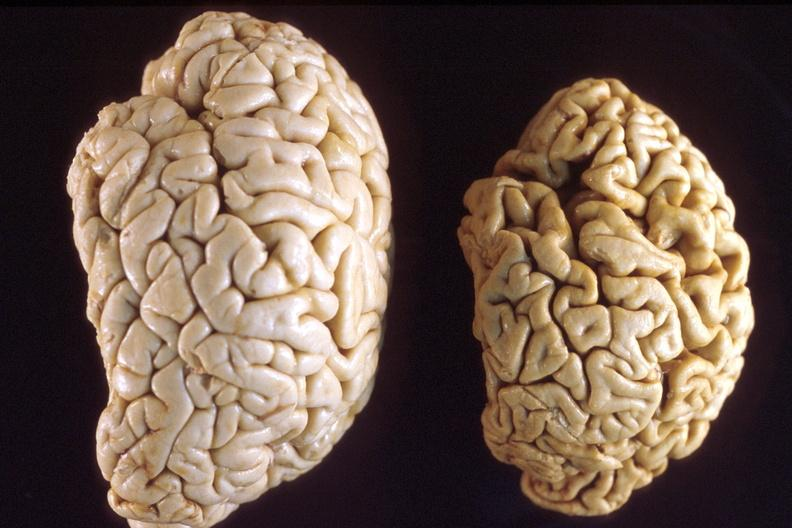what does this image show?
Answer the question using a single word or phrase. Brain 